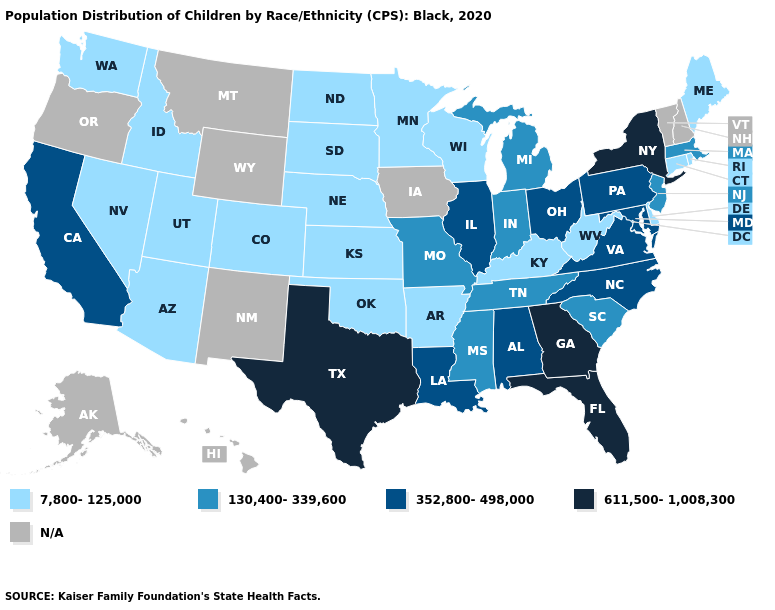Name the states that have a value in the range 352,800-498,000?
Write a very short answer. Alabama, California, Illinois, Louisiana, Maryland, North Carolina, Ohio, Pennsylvania, Virginia. Which states have the lowest value in the USA?
Give a very brief answer. Arizona, Arkansas, Colorado, Connecticut, Delaware, Idaho, Kansas, Kentucky, Maine, Minnesota, Nebraska, Nevada, North Dakota, Oklahoma, Rhode Island, South Dakota, Utah, Washington, West Virginia, Wisconsin. Which states have the lowest value in the USA?
Write a very short answer. Arizona, Arkansas, Colorado, Connecticut, Delaware, Idaho, Kansas, Kentucky, Maine, Minnesota, Nebraska, Nevada, North Dakota, Oklahoma, Rhode Island, South Dakota, Utah, Washington, West Virginia, Wisconsin. What is the value of New Mexico?
Keep it brief. N/A. What is the value of Colorado?
Keep it brief. 7,800-125,000. What is the value of Virginia?
Short answer required. 352,800-498,000. What is the value of Ohio?
Keep it brief. 352,800-498,000. Name the states that have a value in the range 130,400-339,600?
Write a very short answer. Indiana, Massachusetts, Michigan, Mississippi, Missouri, New Jersey, South Carolina, Tennessee. Name the states that have a value in the range N/A?
Write a very short answer. Alaska, Hawaii, Iowa, Montana, New Hampshire, New Mexico, Oregon, Vermont, Wyoming. Name the states that have a value in the range 130,400-339,600?
Keep it brief. Indiana, Massachusetts, Michigan, Mississippi, Missouri, New Jersey, South Carolina, Tennessee. What is the value of California?
Give a very brief answer. 352,800-498,000. Which states have the lowest value in the USA?
Quick response, please. Arizona, Arkansas, Colorado, Connecticut, Delaware, Idaho, Kansas, Kentucky, Maine, Minnesota, Nebraska, Nevada, North Dakota, Oklahoma, Rhode Island, South Dakota, Utah, Washington, West Virginia, Wisconsin. Name the states that have a value in the range 7,800-125,000?
Write a very short answer. Arizona, Arkansas, Colorado, Connecticut, Delaware, Idaho, Kansas, Kentucky, Maine, Minnesota, Nebraska, Nevada, North Dakota, Oklahoma, Rhode Island, South Dakota, Utah, Washington, West Virginia, Wisconsin. What is the value of Minnesota?
Keep it brief. 7,800-125,000. 